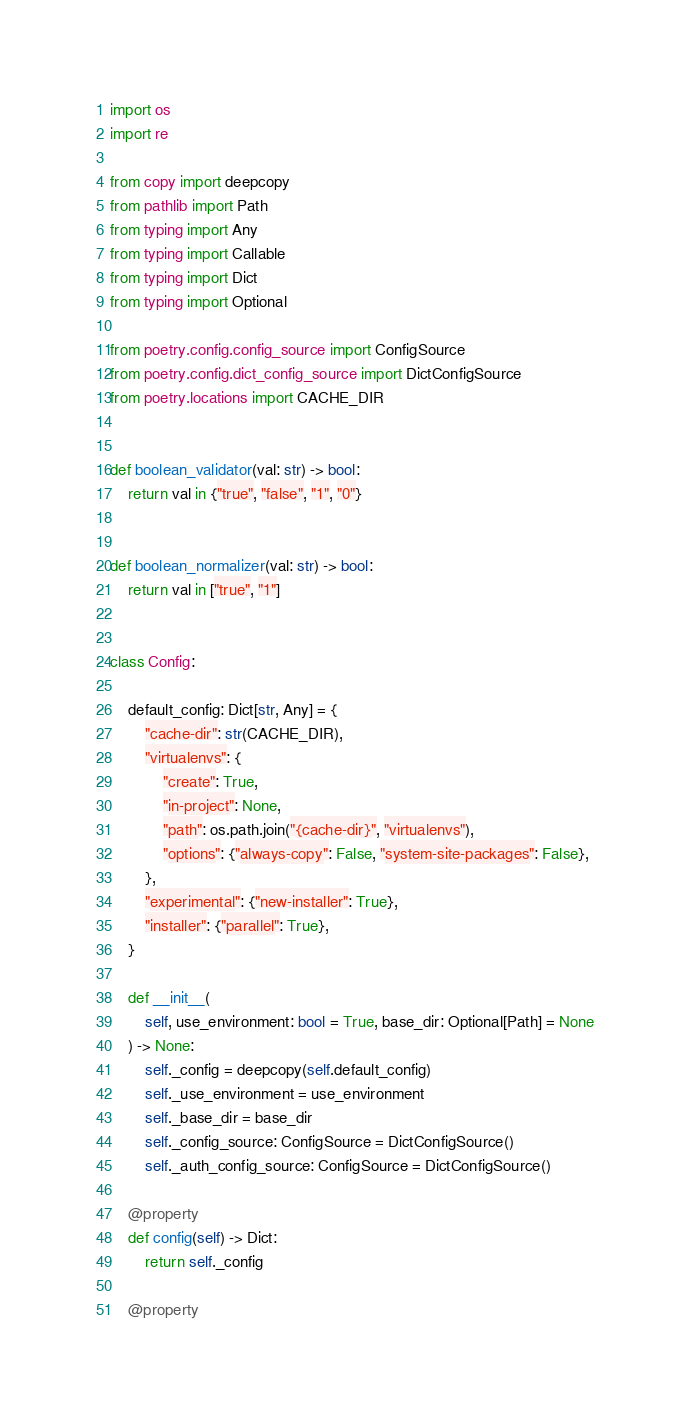Convert code to text. <code><loc_0><loc_0><loc_500><loc_500><_Python_>import os
import re

from copy import deepcopy
from pathlib import Path
from typing import Any
from typing import Callable
from typing import Dict
from typing import Optional

from poetry.config.config_source import ConfigSource
from poetry.config.dict_config_source import DictConfigSource
from poetry.locations import CACHE_DIR


def boolean_validator(val: str) -> bool:
    return val in {"true", "false", "1", "0"}


def boolean_normalizer(val: str) -> bool:
    return val in ["true", "1"]


class Config:

    default_config: Dict[str, Any] = {
        "cache-dir": str(CACHE_DIR),
        "virtualenvs": {
            "create": True,
            "in-project": None,
            "path": os.path.join("{cache-dir}", "virtualenvs"),
            "options": {"always-copy": False, "system-site-packages": False},
        },
        "experimental": {"new-installer": True},
        "installer": {"parallel": True},
    }

    def __init__(
        self, use_environment: bool = True, base_dir: Optional[Path] = None
    ) -> None:
        self._config = deepcopy(self.default_config)
        self._use_environment = use_environment
        self._base_dir = base_dir
        self._config_source: ConfigSource = DictConfigSource()
        self._auth_config_source: ConfigSource = DictConfigSource()

    @property
    def config(self) -> Dict:
        return self._config

    @property</code> 